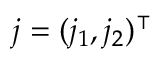<formula> <loc_0><loc_0><loc_500><loc_500>j = ( j _ { 1 } , j _ { 2 } ) ^ { \intercal }</formula> 